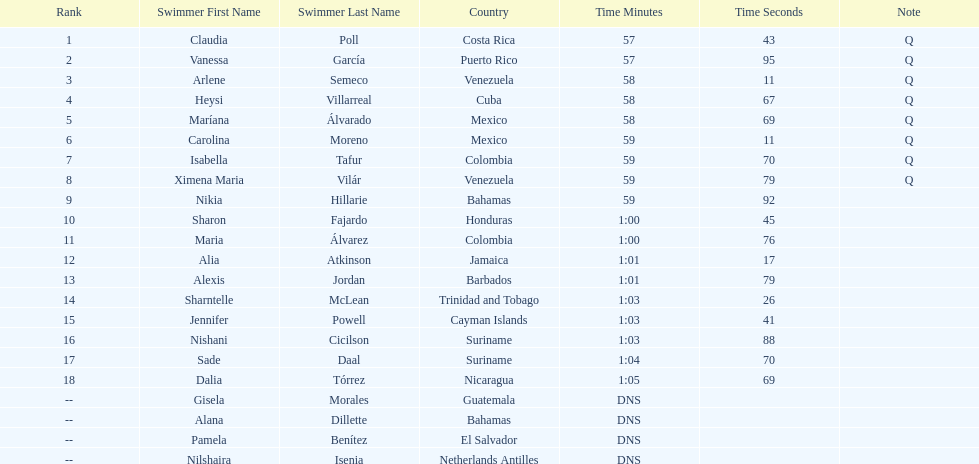Who finished after claudia poll? Vanessa García. 